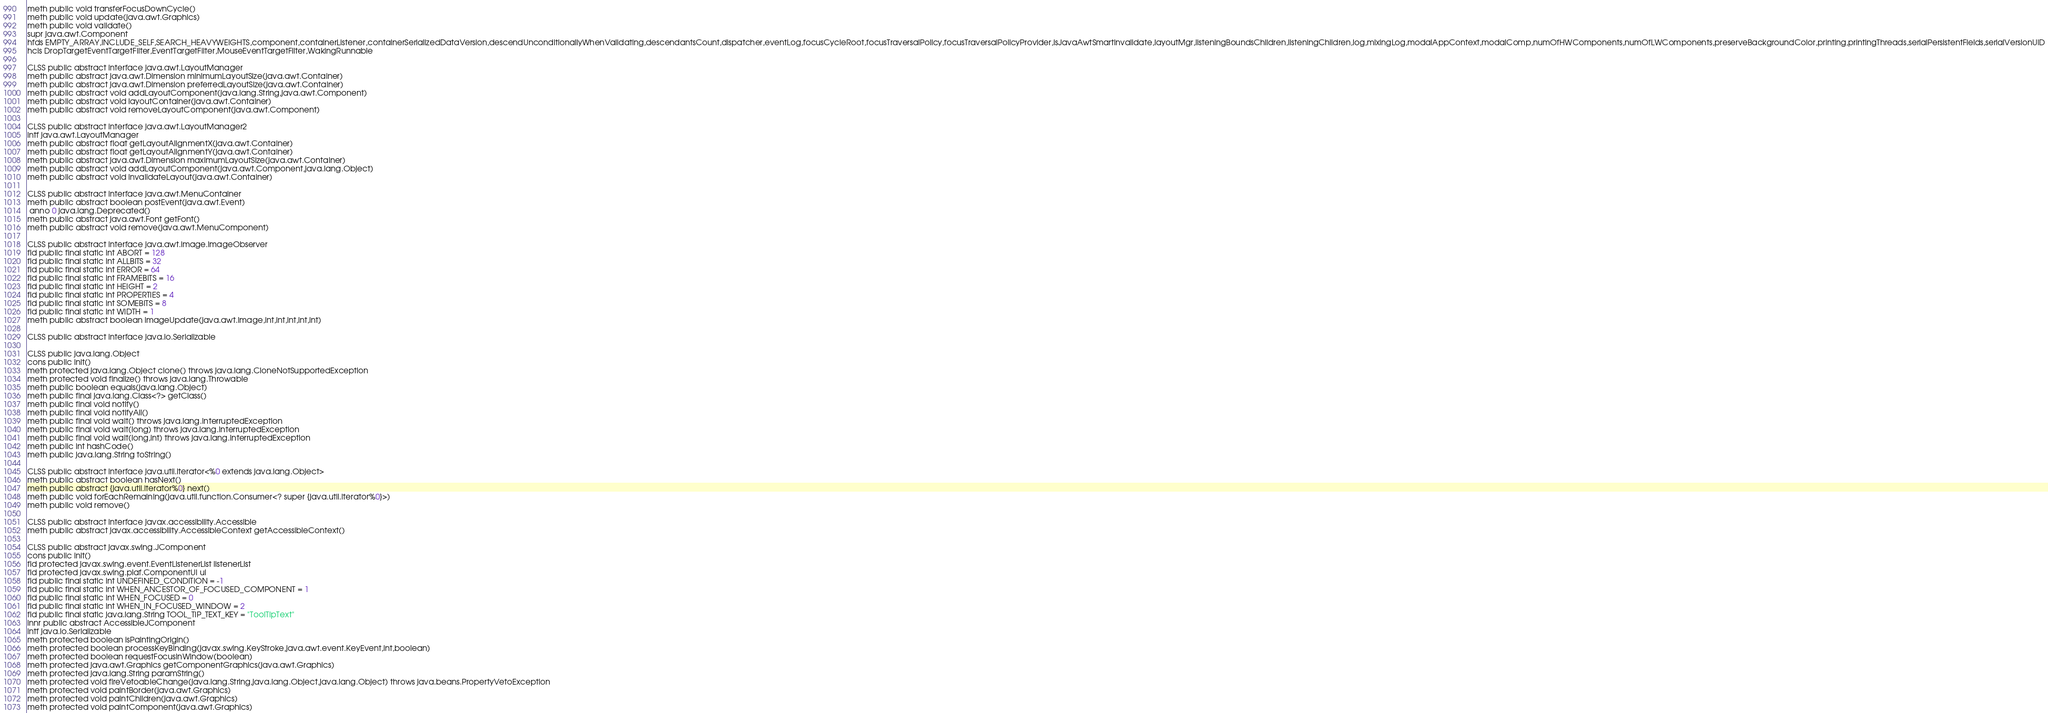<code> <loc_0><loc_0><loc_500><loc_500><_SML_>meth public void transferFocusDownCycle()
meth public void update(java.awt.Graphics)
meth public void validate()
supr java.awt.Component
hfds EMPTY_ARRAY,INCLUDE_SELF,SEARCH_HEAVYWEIGHTS,component,containerListener,containerSerializedDataVersion,descendUnconditionallyWhenValidating,descendantsCount,dispatcher,eventLog,focusCycleRoot,focusTraversalPolicy,focusTraversalPolicyProvider,isJavaAwtSmartInvalidate,layoutMgr,listeningBoundsChildren,listeningChildren,log,mixingLog,modalAppContext,modalComp,numOfHWComponents,numOfLWComponents,preserveBackgroundColor,printing,printingThreads,serialPersistentFields,serialVersionUID
hcls DropTargetEventTargetFilter,EventTargetFilter,MouseEventTargetFilter,WakingRunnable

CLSS public abstract interface java.awt.LayoutManager
meth public abstract java.awt.Dimension minimumLayoutSize(java.awt.Container)
meth public abstract java.awt.Dimension preferredLayoutSize(java.awt.Container)
meth public abstract void addLayoutComponent(java.lang.String,java.awt.Component)
meth public abstract void layoutContainer(java.awt.Container)
meth public abstract void removeLayoutComponent(java.awt.Component)

CLSS public abstract interface java.awt.LayoutManager2
intf java.awt.LayoutManager
meth public abstract float getLayoutAlignmentX(java.awt.Container)
meth public abstract float getLayoutAlignmentY(java.awt.Container)
meth public abstract java.awt.Dimension maximumLayoutSize(java.awt.Container)
meth public abstract void addLayoutComponent(java.awt.Component,java.lang.Object)
meth public abstract void invalidateLayout(java.awt.Container)

CLSS public abstract interface java.awt.MenuContainer
meth public abstract boolean postEvent(java.awt.Event)
 anno 0 java.lang.Deprecated()
meth public abstract java.awt.Font getFont()
meth public abstract void remove(java.awt.MenuComponent)

CLSS public abstract interface java.awt.image.ImageObserver
fld public final static int ABORT = 128
fld public final static int ALLBITS = 32
fld public final static int ERROR = 64
fld public final static int FRAMEBITS = 16
fld public final static int HEIGHT = 2
fld public final static int PROPERTIES = 4
fld public final static int SOMEBITS = 8
fld public final static int WIDTH = 1
meth public abstract boolean imageUpdate(java.awt.Image,int,int,int,int,int)

CLSS public abstract interface java.io.Serializable

CLSS public java.lang.Object
cons public init()
meth protected java.lang.Object clone() throws java.lang.CloneNotSupportedException
meth protected void finalize() throws java.lang.Throwable
meth public boolean equals(java.lang.Object)
meth public final java.lang.Class<?> getClass()
meth public final void notify()
meth public final void notifyAll()
meth public final void wait() throws java.lang.InterruptedException
meth public final void wait(long) throws java.lang.InterruptedException
meth public final void wait(long,int) throws java.lang.InterruptedException
meth public int hashCode()
meth public java.lang.String toString()

CLSS public abstract interface java.util.Iterator<%0 extends java.lang.Object>
meth public abstract boolean hasNext()
meth public abstract {java.util.Iterator%0} next()
meth public void forEachRemaining(java.util.function.Consumer<? super {java.util.Iterator%0}>)
meth public void remove()

CLSS public abstract interface javax.accessibility.Accessible
meth public abstract javax.accessibility.AccessibleContext getAccessibleContext()

CLSS public abstract javax.swing.JComponent
cons public init()
fld protected javax.swing.event.EventListenerList listenerList
fld protected javax.swing.plaf.ComponentUI ui
fld public final static int UNDEFINED_CONDITION = -1
fld public final static int WHEN_ANCESTOR_OF_FOCUSED_COMPONENT = 1
fld public final static int WHEN_FOCUSED = 0
fld public final static int WHEN_IN_FOCUSED_WINDOW = 2
fld public final static java.lang.String TOOL_TIP_TEXT_KEY = "ToolTipText"
innr public abstract AccessibleJComponent
intf java.io.Serializable
meth protected boolean isPaintingOrigin()
meth protected boolean processKeyBinding(javax.swing.KeyStroke,java.awt.event.KeyEvent,int,boolean)
meth protected boolean requestFocusInWindow(boolean)
meth protected java.awt.Graphics getComponentGraphics(java.awt.Graphics)
meth protected java.lang.String paramString()
meth protected void fireVetoableChange(java.lang.String,java.lang.Object,java.lang.Object) throws java.beans.PropertyVetoException
meth protected void paintBorder(java.awt.Graphics)
meth protected void paintChildren(java.awt.Graphics)
meth protected void paintComponent(java.awt.Graphics)</code> 